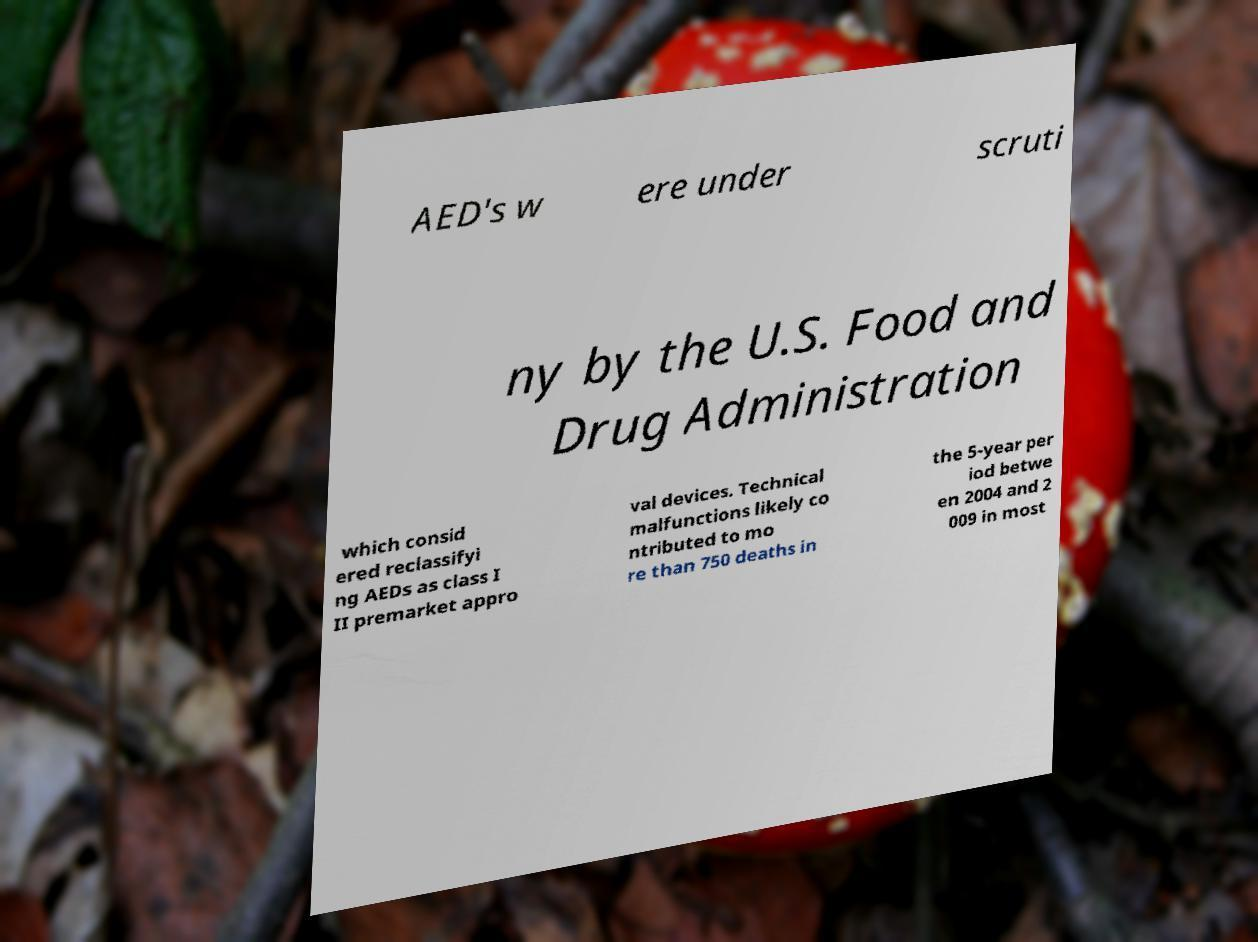For documentation purposes, I need the text within this image transcribed. Could you provide that? AED's w ere under scruti ny by the U.S. Food and Drug Administration which consid ered reclassifyi ng AEDs as class I II premarket appro val devices. Technical malfunctions likely co ntributed to mo re than 750 deaths in the 5-year per iod betwe en 2004 and 2 009 in most 